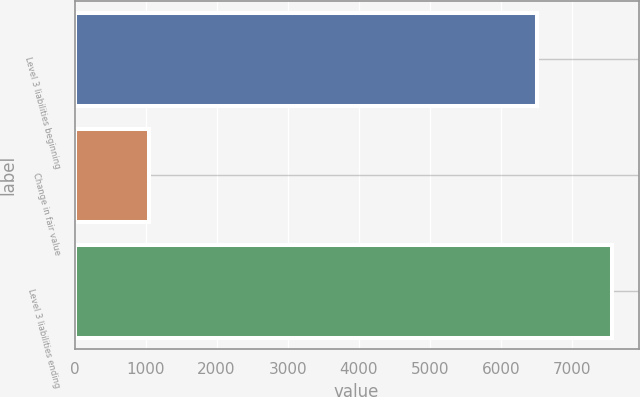Convert chart. <chart><loc_0><loc_0><loc_500><loc_500><bar_chart><fcel>Level 3 liabilities beginning<fcel>Change in fair value<fcel>Level 3 liabilities ending<nl><fcel>6510<fcel>1053<fcel>7563<nl></chart> 